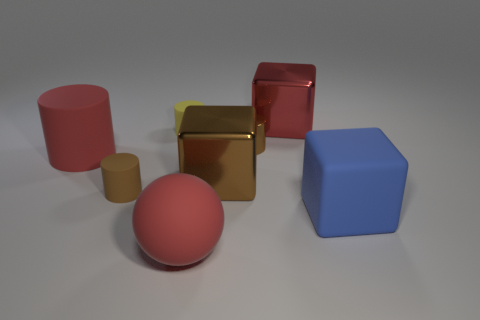Subtract all red cubes. How many brown cylinders are left? 2 Subtract all large metal cubes. How many cubes are left? 1 Add 1 metal things. How many objects exist? 9 Subtract all yellow cylinders. How many cylinders are left? 3 Add 1 red spheres. How many red spheres are left? 2 Add 1 red metallic things. How many red metallic things exist? 2 Subtract 0 cyan balls. How many objects are left? 8 Subtract all spheres. How many objects are left? 7 Subtract all purple cylinders. Subtract all red spheres. How many cylinders are left? 4 Subtract all big yellow metal cylinders. Subtract all balls. How many objects are left? 7 